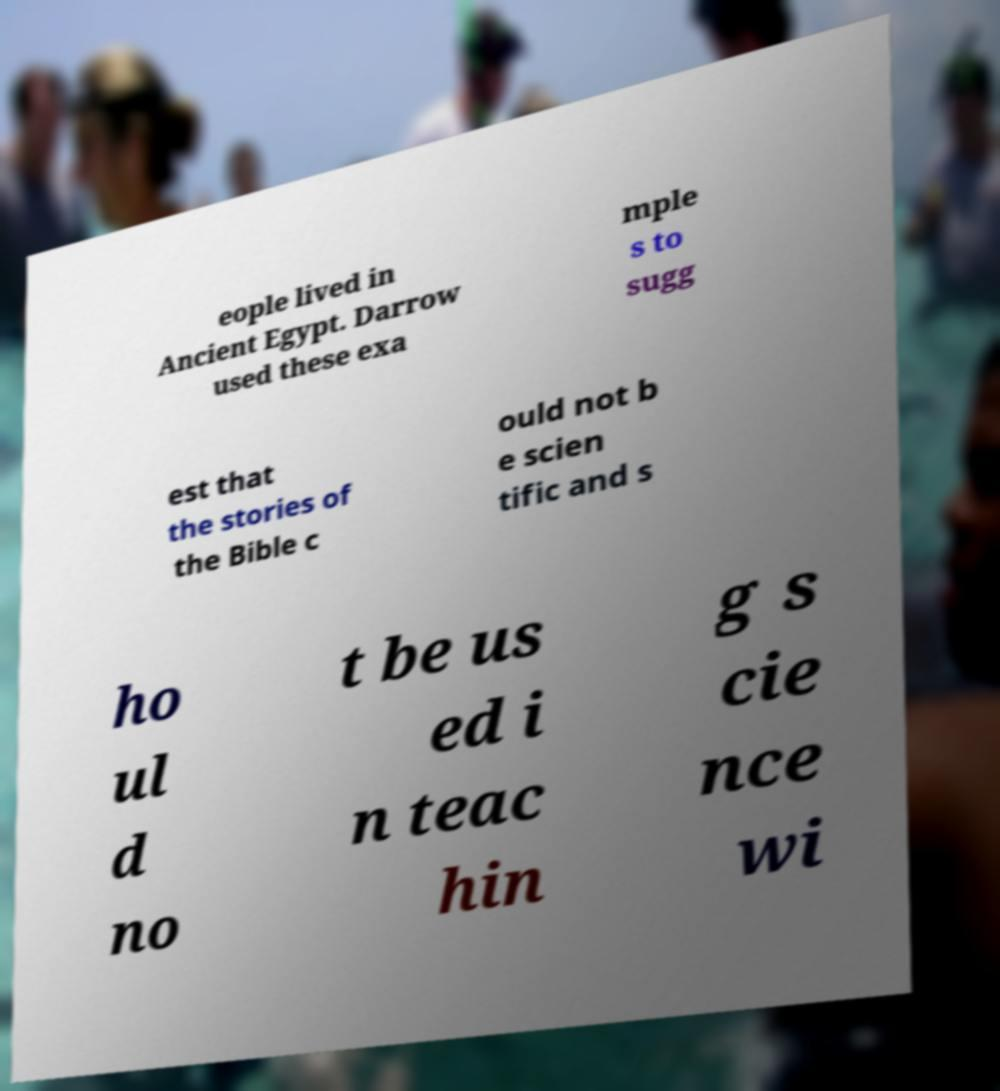For documentation purposes, I need the text within this image transcribed. Could you provide that? eople lived in Ancient Egypt. Darrow used these exa mple s to sugg est that the stories of the Bible c ould not b e scien tific and s ho ul d no t be us ed i n teac hin g s cie nce wi 